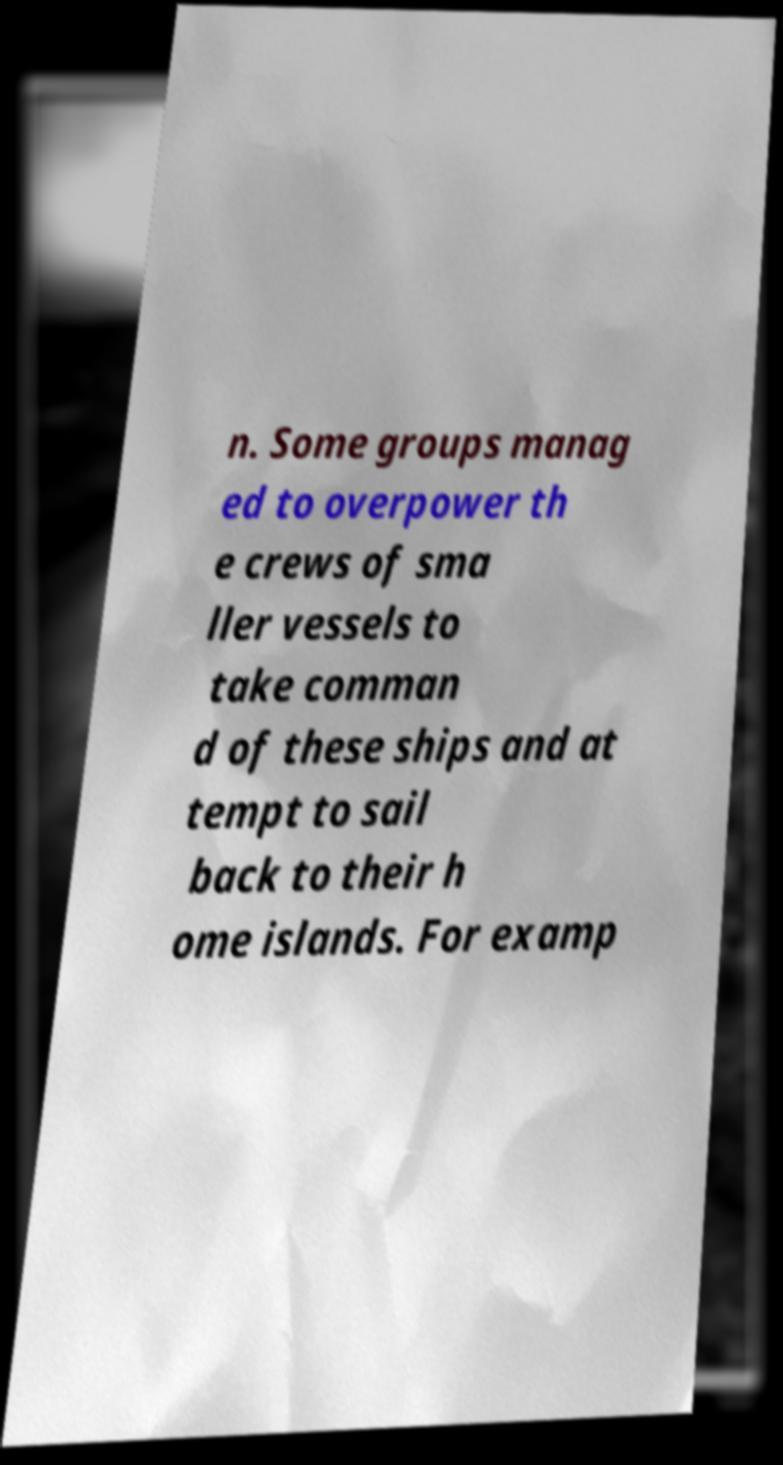What messages or text are displayed in this image? I need them in a readable, typed format. n. Some groups manag ed to overpower th e crews of sma ller vessels to take comman d of these ships and at tempt to sail back to their h ome islands. For examp 